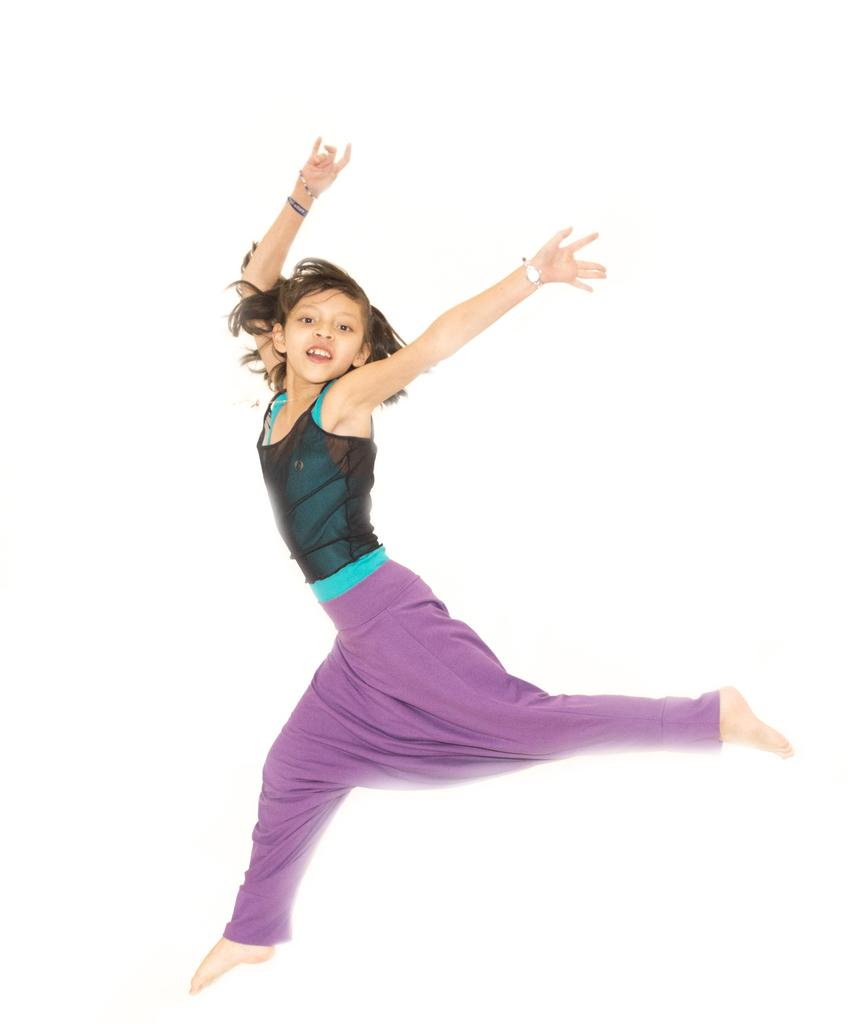Who is the main subject in the image? There is a girl in the image. What can be seen behind the girl in the image? The background of the image is white. Can you see any ducks in the image? There are no ducks present in the image. What type of airport is visible in the background of the image? There is no airport present in the image; the background is white. 